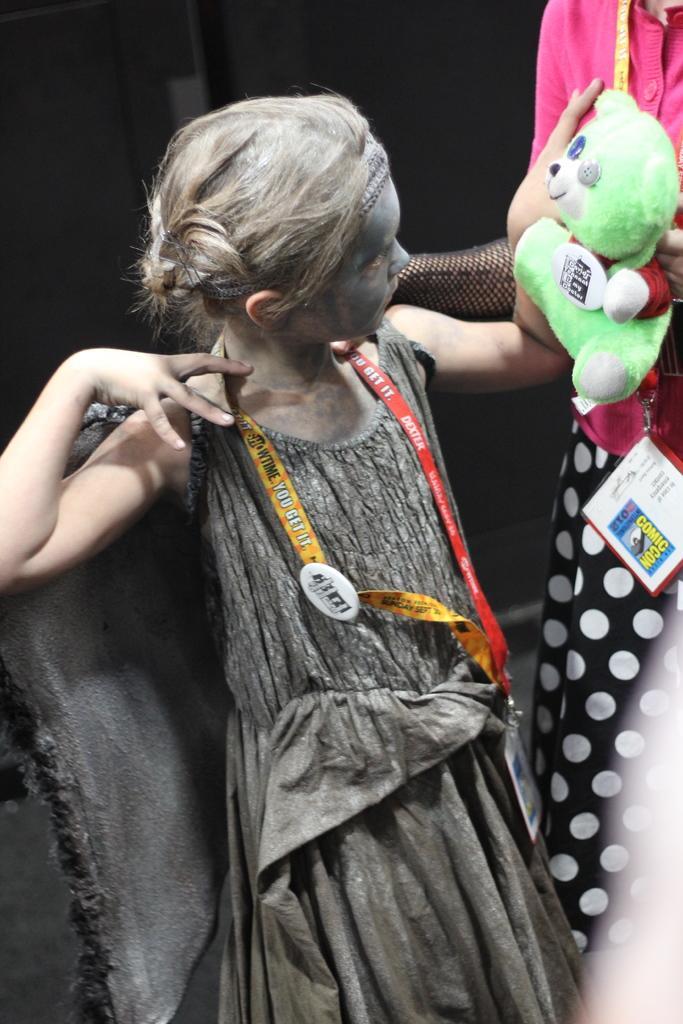Could you give a brief overview of what you see in this image? In this image we can see a girl holding a teddy bear in her hand and seeing towards the teddy bear and there is a girl standing beside her in black and pink dress. 